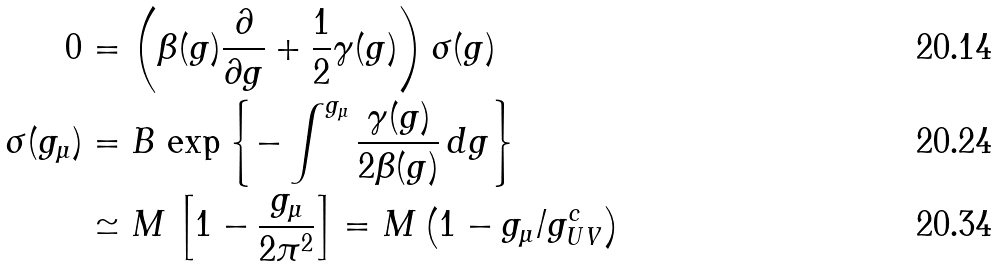<formula> <loc_0><loc_0><loc_500><loc_500>0 & = \left ( \beta ( g ) \frac { \partial } { \partial g } + \frac { 1 } { 2 } \gamma ( g ) \right ) \sigma ( g ) & \\ \sigma ( g _ { \mu } ) & = B \, \exp { \left \{ - \int ^ { g _ { \mu } } \frac { \gamma ( g ) } { 2 \beta ( g ) } \, d g \right \} } \\ & \simeq M \, \left [ 1 - \frac { g _ { \mu } } { 2 \pi ^ { 2 } } \right ] = M \left ( 1 - g _ { \mu } / g _ { U V } ^ { c } \right )</formula> 